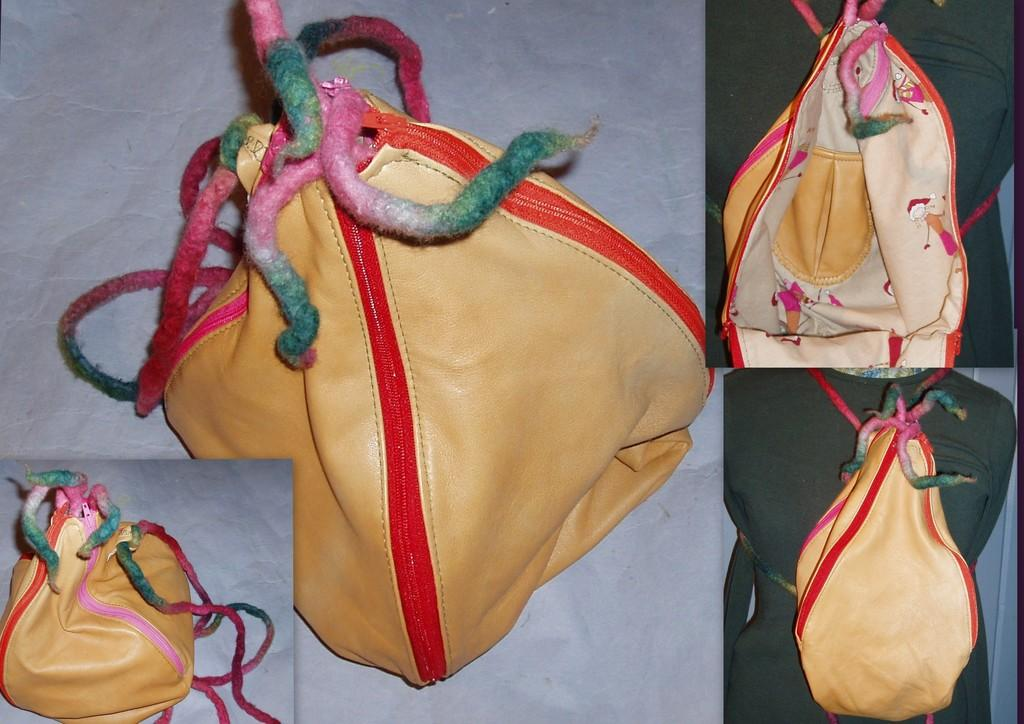What is the main subject of the image? The main subject of the image is a collage of pictures. Are there any other objects or people in the image? Yes, there is a bag and a person carrying the bag in the image. What type of business is being conducted in the image? There is no indication of any business being conducted in the image. 